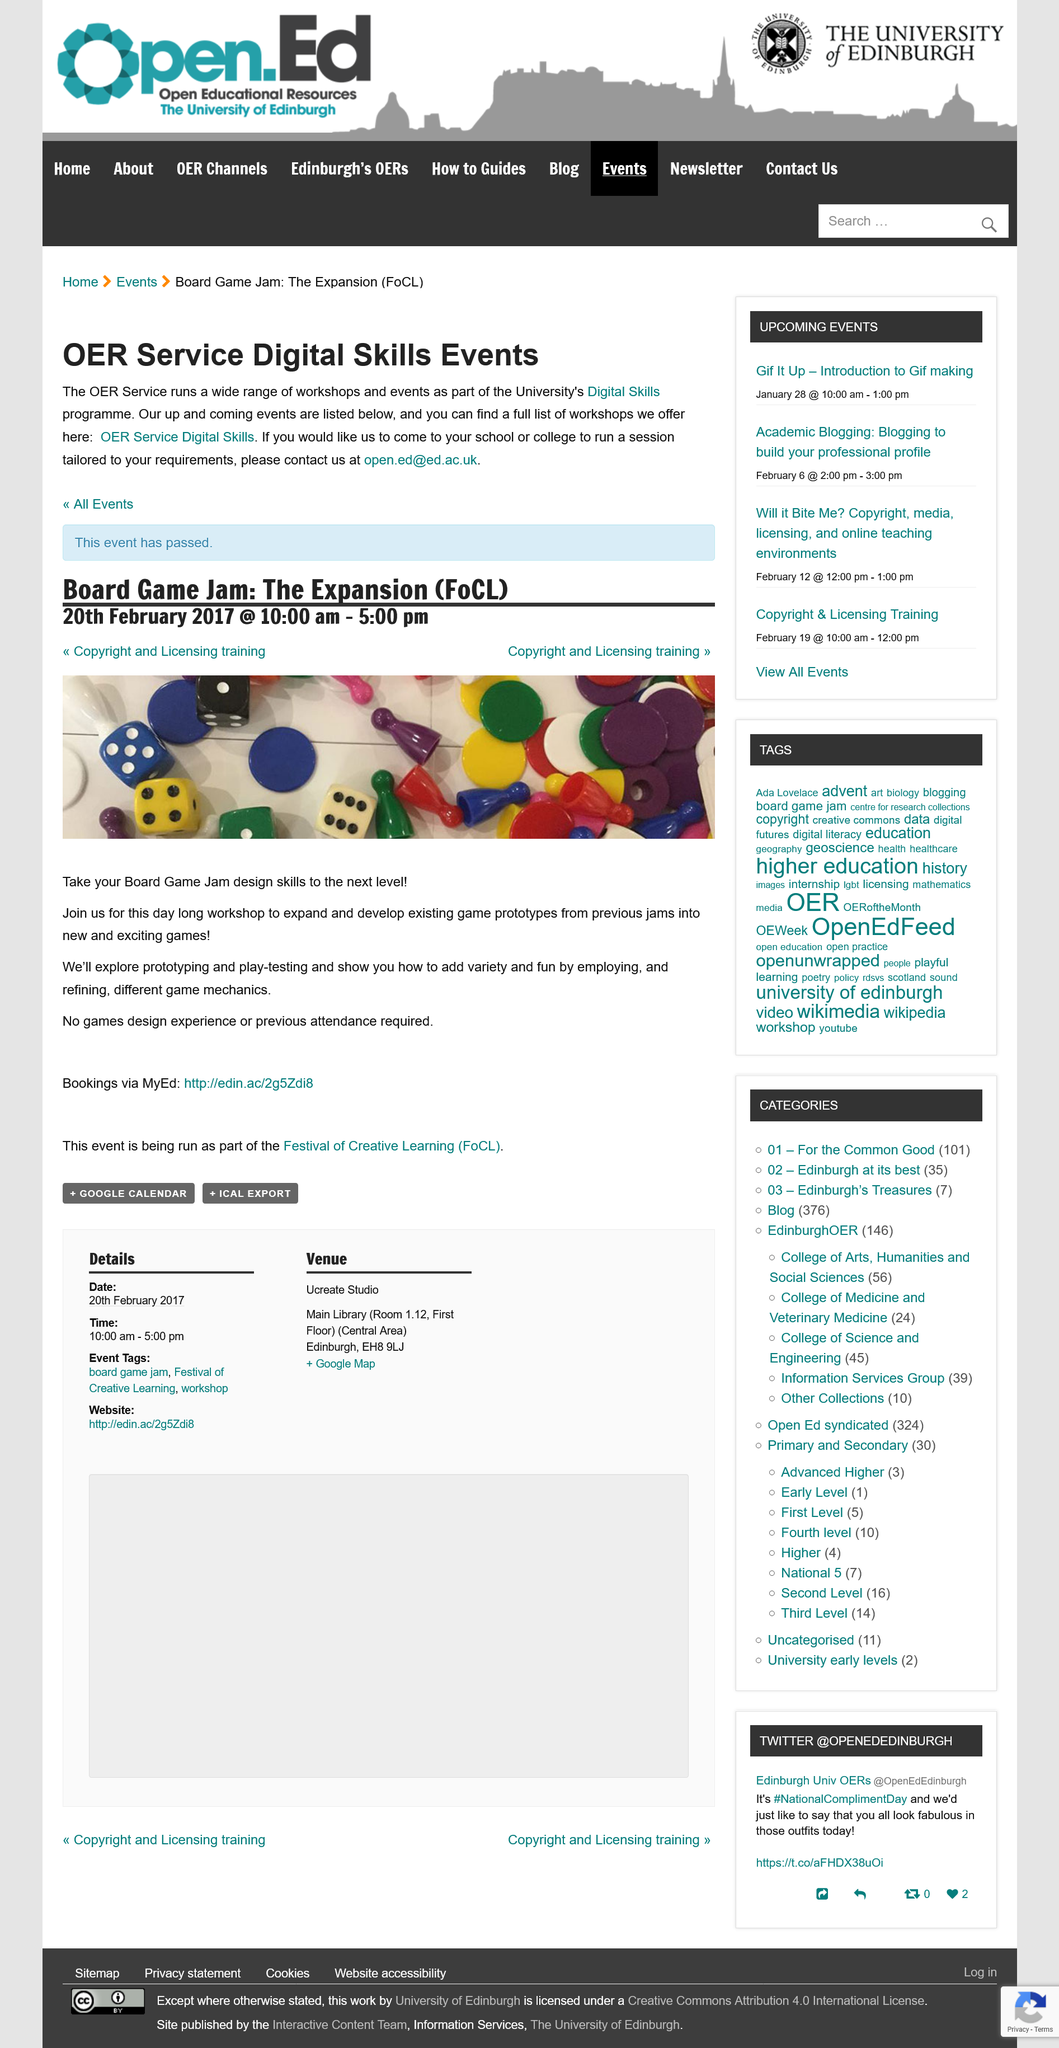Draw attention to some important aspects in this diagram. It is not necessary to have attended previously. The Board Game Jam: The Expansion will take place on February 20, 2017. It is not necessary to have any experience in game design to attend this event. 